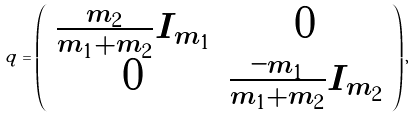<formula> <loc_0><loc_0><loc_500><loc_500>q = \left ( \begin{array} { c c } \frac { m _ { 2 } } { m _ { 1 } + m _ { 2 } } I _ { m _ { 1 } } & 0 \\ 0 & \frac { - m _ { 1 } } { m _ { 1 } + m _ { 2 } } I _ { m _ { 2 } } \end{array} \right ) ,</formula> 